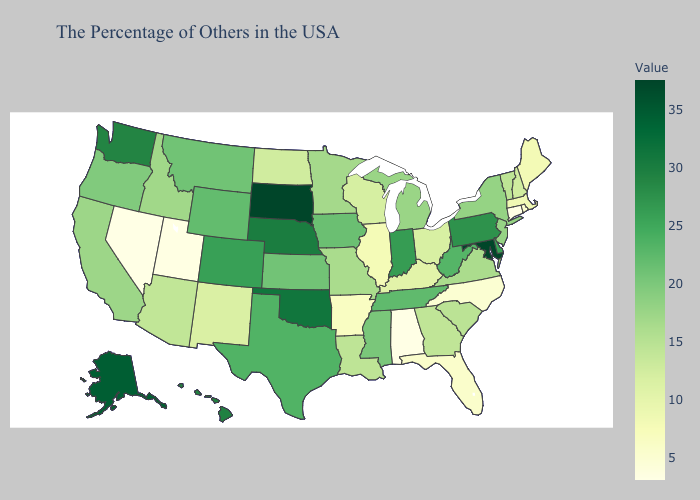Does Alabama have the lowest value in the South?
Quick response, please. Yes. Does the map have missing data?
Write a very short answer. No. 